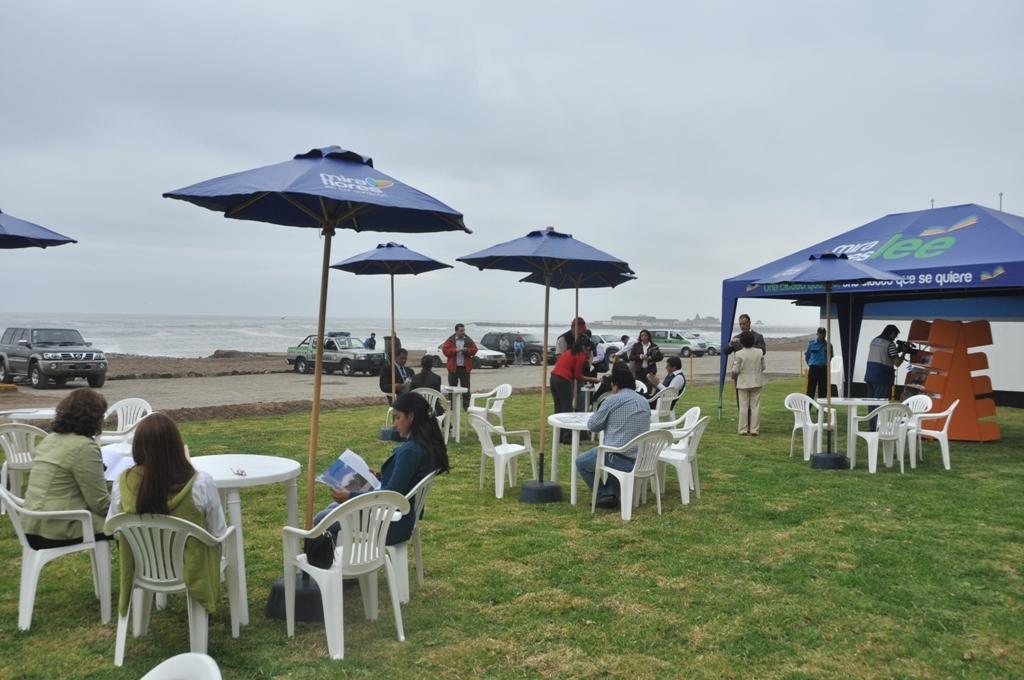Could you give a brief overview of what you see in this image? As we can see in the image there are humans, tables, chairs, umbrellas, water and cars. 